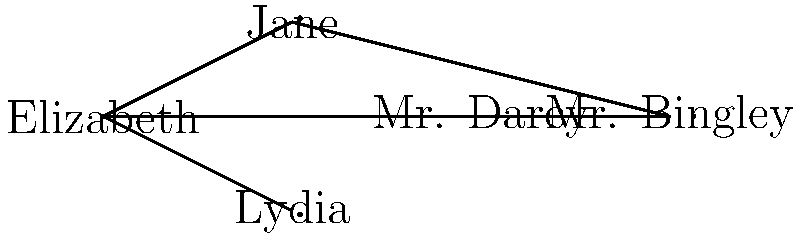In Jane Austen's "Pride and Prejudice," consider the graph representing character relationships. What is the minimum number of characters that need to be removed to disconnect Mr. Darcy from Mr. Bingley? To solve this problem, we need to analyze the connectivity between Mr. Darcy and Mr. Bingley in the given graph. Let's follow these steps:

1. Identify the nodes representing Mr. Darcy and Mr. Bingley:
   - Mr. Darcy is the fourth node from the left
   - Mr. Bingley is the rightmost node

2. Observe the paths connecting Mr. Darcy and Mr. Bingley:
   a. Direct path: Mr. Darcy -- Mr. Bingley
   b. Indirect path: Mr. Darcy -- Elizabeth -- Jane -- Mr. Bingley

3. To disconnect Mr. Darcy from Mr. Bingley, we need to remove all paths between them:
   - Removing Elizabeth would disconnect the indirect path but not the direct path
   - Removing either Mr. Darcy or Mr. Bingley would disconnect both paths, but this is not the minimum number of removals

4. The minimum number of characters to remove is 1, which can be achieved by removing either:
   - The direct edge between Mr. Darcy and Mr. Bingley, or
   - Mr. Darcy himself, or
   - Mr. Bingley himself

5. Since the question asks for the number of characters (nodes) to be removed, not edges, the answer is 1.

Therefore, the minimum number of characters that need to be removed to disconnect Mr. Darcy from Mr. Bingley is 1.
Answer: 1 